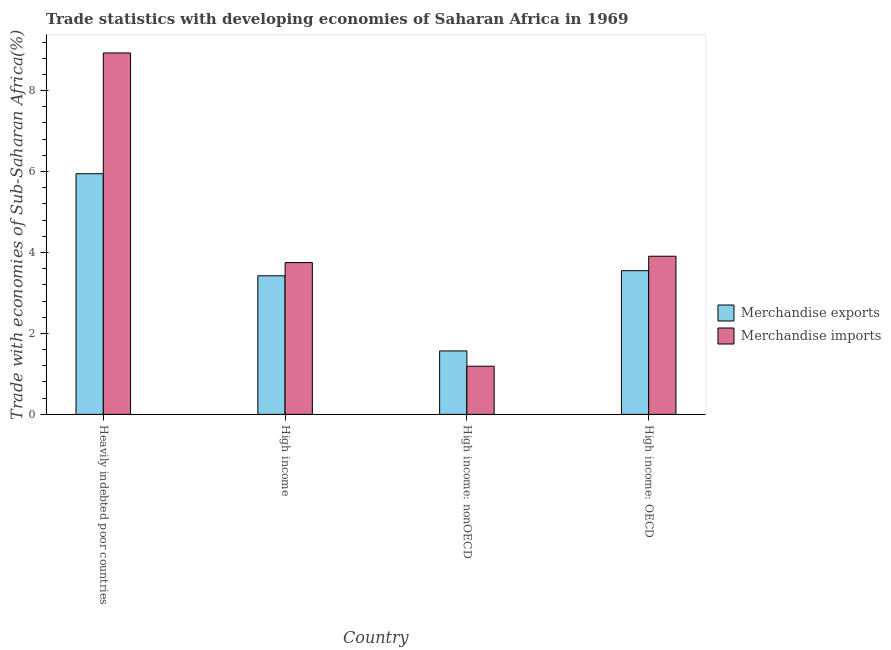Are the number of bars per tick equal to the number of legend labels?
Give a very brief answer. Yes. What is the label of the 1st group of bars from the left?
Your response must be concise. Heavily indebted poor countries. In how many cases, is the number of bars for a given country not equal to the number of legend labels?
Your answer should be very brief. 0. What is the merchandise exports in High income: OECD?
Ensure brevity in your answer.  3.55. Across all countries, what is the maximum merchandise imports?
Offer a very short reply. 8.93. Across all countries, what is the minimum merchandise exports?
Keep it short and to the point. 1.57. In which country was the merchandise imports maximum?
Offer a terse response. Heavily indebted poor countries. In which country was the merchandise exports minimum?
Your response must be concise. High income: nonOECD. What is the total merchandise exports in the graph?
Provide a short and direct response. 14.49. What is the difference between the merchandise exports in Heavily indebted poor countries and that in High income: nonOECD?
Provide a succinct answer. 4.38. What is the difference between the merchandise imports in Heavily indebted poor countries and the merchandise exports in High income: nonOECD?
Keep it short and to the point. 7.36. What is the average merchandise exports per country?
Provide a short and direct response. 3.62. What is the difference between the merchandise exports and merchandise imports in Heavily indebted poor countries?
Your answer should be very brief. -2.98. In how many countries, is the merchandise exports greater than 4.8 %?
Offer a terse response. 1. What is the ratio of the merchandise imports in High income to that in High income: OECD?
Your answer should be very brief. 0.96. Is the difference between the merchandise imports in Heavily indebted poor countries and High income greater than the difference between the merchandise exports in Heavily indebted poor countries and High income?
Your answer should be compact. Yes. What is the difference between the highest and the second highest merchandise exports?
Provide a succinct answer. 2.4. What is the difference between the highest and the lowest merchandise exports?
Provide a succinct answer. 4.38. Are all the bars in the graph horizontal?
Provide a short and direct response. No. How many countries are there in the graph?
Your answer should be very brief. 4. What is the difference between two consecutive major ticks on the Y-axis?
Keep it short and to the point. 2. Are the values on the major ticks of Y-axis written in scientific E-notation?
Provide a succinct answer. No. Where does the legend appear in the graph?
Your answer should be compact. Center right. How are the legend labels stacked?
Make the answer very short. Vertical. What is the title of the graph?
Provide a short and direct response. Trade statistics with developing economies of Saharan Africa in 1969. What is the label or title of the Y-axis?
Give a very brief answer. Trade with economies of Sub-Saharan Africa(%). What is the Trade with economies of Sub-Saharan Africa(%) of Merchandise exports in Heavily indebted poor countries?
Ensure brevity in your answer.  5.95. What is the Trade with economies of Sub-Saharan Africa(%) of Merchandise imports in Heavily indebted poor countries?
Give a very brief answer. 8.93. What is the Trade with economies of Sub-Saharan Africa(%) of Merchandise exports in High income?
Keep it short and to the point. 3.42. What is the Trade with economies of Sub-Saharan Africa(%) in Merchandise imports in High income?
Your answer should be compact. 3.75. What is the Trade with economies of Sub-Saharan Africa(%) in Merchandise exports in High income: nonOECD?
Make the answer very short. 1.57. What is the Trade with economies of Sub-Saharan Africa(%) of Merchandise imports in High income: nonOECD?
Your answer should be very brief. 1.19. What is the Trade with economies of Sub-Saharan Africa(%) in Merchandise exports in High income: OECD?
Provide a succinct answer. 3.55. What is the Trade with economies of Sub-Saharan Africa(%) of Merchandise imports in High income: OECD?
Make the answer very short. 3.91. Across all countries, what is the maximum Trade with economies of Sub-Saharan Africa(%) of Merchandise exports?
Your response must be concise. 5.95. Across all countries, what is the maximum Trade with economies of Sub-Saharan Africa(%) of Merchandise imports?
Your answer should be very brief. 8.93. Across all countries, what is the minimum Trade with economies of Sub-Saharan Africa(%) of Merchandise exports?
Your answer should be very brief. 1.57. Across all countries, what is the minimum Trade with economies of Sub-Saharan Africa(%) in Merchandise imports?
Offer a terse response. 1.19. What is the total Trade with economies of Sub-Saharan Africa(%) of Merchandise exports in the graph?
Give a very brief answer. 14.49. What is the total Trade with economies of Sub-Saharan Africa(%) in Merchandise imports in the graph?
Keep it short and to the point. 17.78. What is the difference between the Trade with economies of Sub-Saharan Africa(%) in Merchandise exports in Heavily indebted poor countries and that in High income?
Offer a terse response. 2.52. What is the difference between the Trade with economies of Sub-Saharan Africa(%) of Merchandise imports in Heavily indebted poor countries and that in High income?
Offer a terse response. 5.18. What is the difference between the Trade with economies of Sub-Saharan Africa(%) in Merchandise exports in Heavily indebted poor countries and that in High income: nonOECD?
Provide a succinct answer. 4.38. What is the difference between the Trade with economies of Sub-Saharan Africa(%) in Merchandise imports in Heavily indebted poor countries and that in High income: nonOECD?
Your answer should be very brief. 7.74. What is the difference between the Trade with economies of Sub-Saharan Africa(%) in Merchandise exports in Heavily indebted poor countries and that in High income: OECD?
Your answer should be compact. 2.4. What is the difference between the Trade with economies of Sub-Saharan Africa(%) of Merchandise imports in Heavily indebted poor countries and that in High income: OECD?
Give a very brief answer. 5.02. What is the difference between the Trade with economies of Sub-Saharan Africa(%) in Merchandise exports in High income and that in High income: nonOECD?
Ensure brevity in your answer.  1.86. What is the difference between the Trade with economies of Sub-Saharan Africa(%) in Merchandise imports in High income and that in High income: nonOECD?
Your answer should be very brief. 2.56. What is the difference between the Trade with economies of Sub-Saharan Africa(%) in Merchandise exports in High income and that in High income: OECD?
Keep it short and to the point. -0.13. What is the difference between the Trade with economies of Sub-Saharan Africa(%) of Merchandise imports in High income and that in High income: OECD?
Make the answer very short. -0.16. What is the difference between the Trade with economies of Sub-Saharan Africa(%) in Merchandise exports in High income: nonOECD and that in High income: OECD?
Your answer should be very brief. -1.98. What is the difference between the Trade with economies of Sub-Saharan Africa(%) of Merchandise imports in High income: nonOECD and that in High income: OECD?
Your response must be concise. -2.72. What is the difference between the Trade with economies of Sub-Saharan Africa(%) of Merchandise exports in Heavily indebted poor countries and the Trade with economies of Sub-Saharan Africa(%) of Merchandise imports in High income?
Offer a very short reply. 2.2. What is the difference between the Trade with economies of Sub-Saharan Africa(%) of Merchandise exports in Heavily indebted poor countries and the Trade with economies of Sub-Saharan Africa(%) of Merchandise imports in High income: nonOECD?
Your answer should be very brief. 4.76. What is the difference between the Trade with economies of Sub-Saharan Africa(%) of Merchandise exports in Heavily indebted poor countries and the Trade with economies of Sub-Saharan Africa(%) of Merchandise imports in High income: OECD?
Provide a succinct answer. 2.04. What is the difference between the Trade with economies of Sub-Saharan Africa(%) in Merchandise exports in High income and the Trade with economies of Sub-Saharan Africa(%) in Merchandise imports in High income: nonOECD?
Offer a very short reply. 2.23. What is the difference between the Trade with economies of Sub-Saharan Africa(%) of Merchandise exports in High income and the Trade with economies of Sub-Saharan Africa(%) of Merchandise imports in High income: OECD?
Make the answer very short. -0.48. What is the difference between the Trade with economies of Sub-Saharan Africa(%) in Merchandise exports in High income: nonOECD and the Trade with economies of Sub-Saharan Africa(%) in Merchandise imports in High income: OECD?
Ensure brevity in your answer.  -2.34. What is the average Trade with economies of Sub-Saharan Africa(%) in Merchandise exports per country?
Provide a short and direct response. 3.62. What is the average Trade with economies of Sub-Saharan Africa(%) of Merchandise imports per country?
Offer a terse response. 4.44. What is the difference between the Trade with economies of Sub-Saharan Africa(%) of Merchandise exports and Trade with economies of Sub-Saharan Africa(%) of Merchandise imports in Heavily indebted poor countries?
Offer a very short reply. -2.98. What is the difference between the Trade with economies of Sub-Saharan Africa(%) in Merchandise exports and Trade with economies of Sub-Saharan Africa(%) in Merchandise imports in High income?
Ensure brevity in your answer.  -0.33. What is the difference between the Trade with economies of Sub-Saharan Africa(%) of Merchandise exports and Trade with economies of Sub-Saharan Africa(%) of Merchandise imports in High income: nonOECD?
Offer a very short reply. 0.38. What is the difference between the Trade with economies of Sub-Saharan Africa(%) of Merchandise exports and Trade with economies of Sub-Saharan Africa(%) of Merchandise imports in High income: OECD?
Keep it short and to the point. -0.36. What is the ratio of the Trade with economies of Sub-Saharan Africa(%) of Merchandise exports in Heavily indebted poor countries to that in High income?
Offer a terse response. 1.74. What is the ratio of the Trade with economies of Sub-Saharan Africa(%) in Merchandise imports in Heavily indebted poor countries to that in High income?
Your response must be concise. 2.38. What is the ratio of the Trade with economies of Sub-Saharan Africa(%) in Merchandise exports in Heavily indebted poor countries to that in High income: nonOECD?
Your response must be concise. 3.79. What is the ratio of the Trade with economies of Sub-Saharan Africa(%) of Merchandise imports in Heavily indebted poor countries to that in High income: nonOECD?
Provide a short and direct response. 7.51. What is the ratio of the Trade with economies of Sub-Saharan Africa(%) in Merchandise exports in Heavily indebted poor countries to that in High income: OECD?
Provide a succinct answer. 1.67. What is the ratio of the Trade with economies of Sub-Saharan Africa(%) in Merchandise imports in Heavily indebted poor countries to that in High income: OECD?
Offer a terse response. 2.29. What is the ratio of the Trade with economies of Sub-Saharan Africa(%) in Merchandise exports in High income to that in High income: nonOECD?
Offer a terse response. 2.18. What is the ratio of the Trade with economies of Sub-Saharan Africa(%) in Merchandise imports in High income to that in High income: nonOECD?
Your answer should be compact. 3.15. What is the ratio of the Trade with economies of Sub-Saharan Africa(%) in Merchandise exports in High income to that in High income: OECD?
Ensure brevity in your answer.  0.96. What is the ratio of the Trade with economies of Sub-Saharan Africa(%) in Merchandise imports in High income to that in High income: OECD?
Ensure brevity in your answer.  0.96. What is the ratio of the Trade with economies of Sub-Saharan Africa(%) in Merchandise exports in High income: nonOECD to that in High income: OECD?
Your answer should be very brief. 0.44. What is the ratio of the Trade with economies of Sub-Saharan Africa(%) of Merchandise imports in High income: nonOECD to that in High income: OECD?
Provide a short and direct response. 0.3. What is the difference between the highest and the second highest Trade with economies of Sub-Saharan Africa(%) in Merchandise exports?
Your answer should be very brief. 2.4. What is the difference between the highest and the second highest Trade with economies of Sub-Saharan Africa(%) of Merchandise imports?
Offer a very short reply. 5.02. What is the difference between the highest and the lowest Trade with economies of Sub-Saharan Africa(%) in Merchandise exports?
Provide a succinct answer. 4.38. What is the difference between the highest and the lowest Trade with economies of Sub-Saharan Africa(%) in Merchandise imports?
Offer a very short reply. 7.74. 